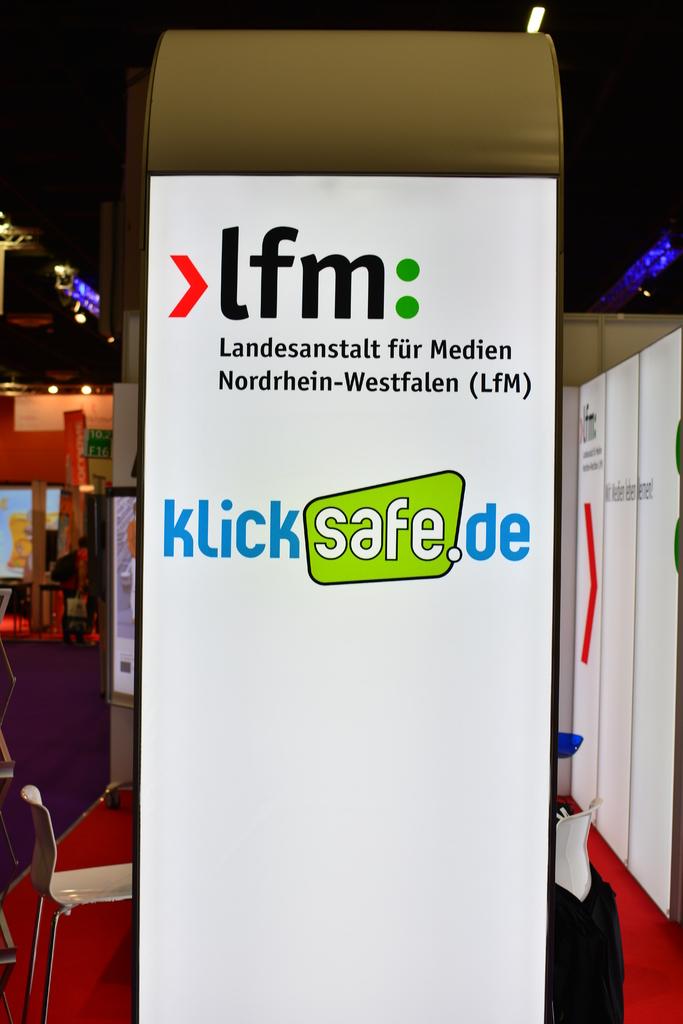What is the website?
Make the answer very short. Klicksafe.de. What is the company's name?
Your answer should be compact. Lfm. 